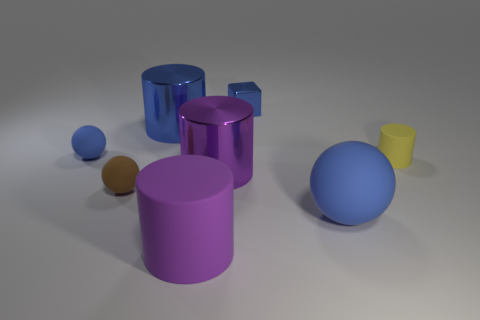Can you describe the shapes of the objects in the image? Certainly! The image shows geometric shapes: there are two spheres, three cylinders of differing heights and one cube. Which object appears to be the largest? The largest object, based on its height and volume, seems to be the purple cylinder situated in the front. 